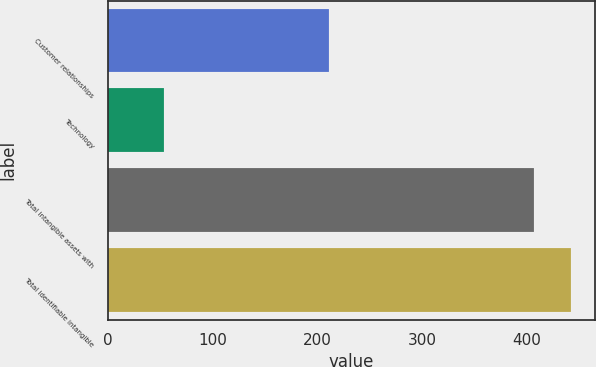Convert chart. <chart><loc_0><loc_0><loc_500><loc_500><bar_chart><fcel>Customer relationships<fcel>Technology<fcel>Total intangible assets with<fcel>Total identifiable intangible<nl><fcel>210.8<fcel>53.2<fcel>406.9<fcel>442.27<nl></chart> 